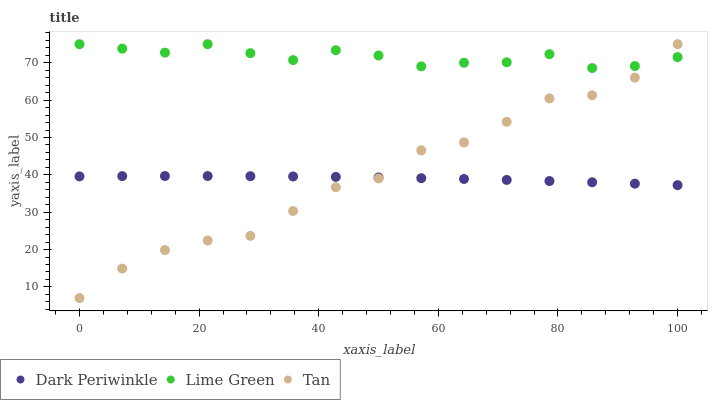Does Dark Periwinkle have the minimum area under the curve?
Answer yes or no. Yes. Does Lime Green have the maximum area under the curve?
Answer yes or no. Yes. Does Lime Green have the minimum area under the curve?
Answer yes or no. No. Does Dark Periwinkle have the maximum area under the curve?
Answer yes or no. No. Is Dark Periwinkle the smoothest?
Answer yes or no. Yes. Is Tan the roughest?
Answer yes or no. Yes. Is Lime Green the smoothest?
Answer yes or no. No. Is Lime Green the roughest?
Answer yes or no. No. Does Tan have the lowest value?
Answer yes or no. Yes. Does Dark Periwinkle have the lowest value?
Answer yes or no. No. Does Lime Green have the highest value?
Answer yes or no. Yes. Does Dark Periwinkle have the highest value?
Answer yes or no. No. Is Dark Periwinkle less than Lime Green?
Answer yes or no. Yes. Is Lime Green greater than Dark Periwinkle?
Answer yes or no. Yes. Does Tan intersect Dark Periwinkle?
Answer yes or no. Yes. Is Tan less than Dark Periwinkle?
Answer yes or no. No. Is Tan greater than Dark Periwinkle?
Answer yes or no. No. Does Dark Periwinkle intersect Lime Green?
Answer yes or no. No. 